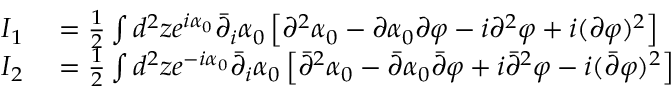Convert formula to latex. <formula><loc_0><loc_0><loc_500><loc_500>\begin{array} { r l } { I _ { 1 } } & = \frac { 1 } { 2 } \int d ^ { 2 } z e ^ { i \alpha _ { 0 } } \bar { \partial } _ { i } \alpha _ { 0 } \left [ \partial ^ { 2 } \alpha _ { 0 } - \partial \alpha _ { 0 } \partial \varphi - i \partial ^ { 2 } \varphi + i ( \partial \varphi ) ^ { 2 } \right ] } \\ { I _ { 2 } } & = \frac { 1 } { 2 } \int d ^ { 2 } z e ^ { - i \alpha _ { 0 } } \bar { \partial } _ { i } \alpha _ { 0 } \left [ \bar { \partial } ^ { 2 } \alpha _ { 0 } - \bar { \partial } \alpha _ { 0 } \bar { \partial } \varphi + i \bar { \partial } ^ { 2 } \varphi - i ( \bar { \partial } \varphi ) ^ { 2 } \right ] } \end{array}</formula> 